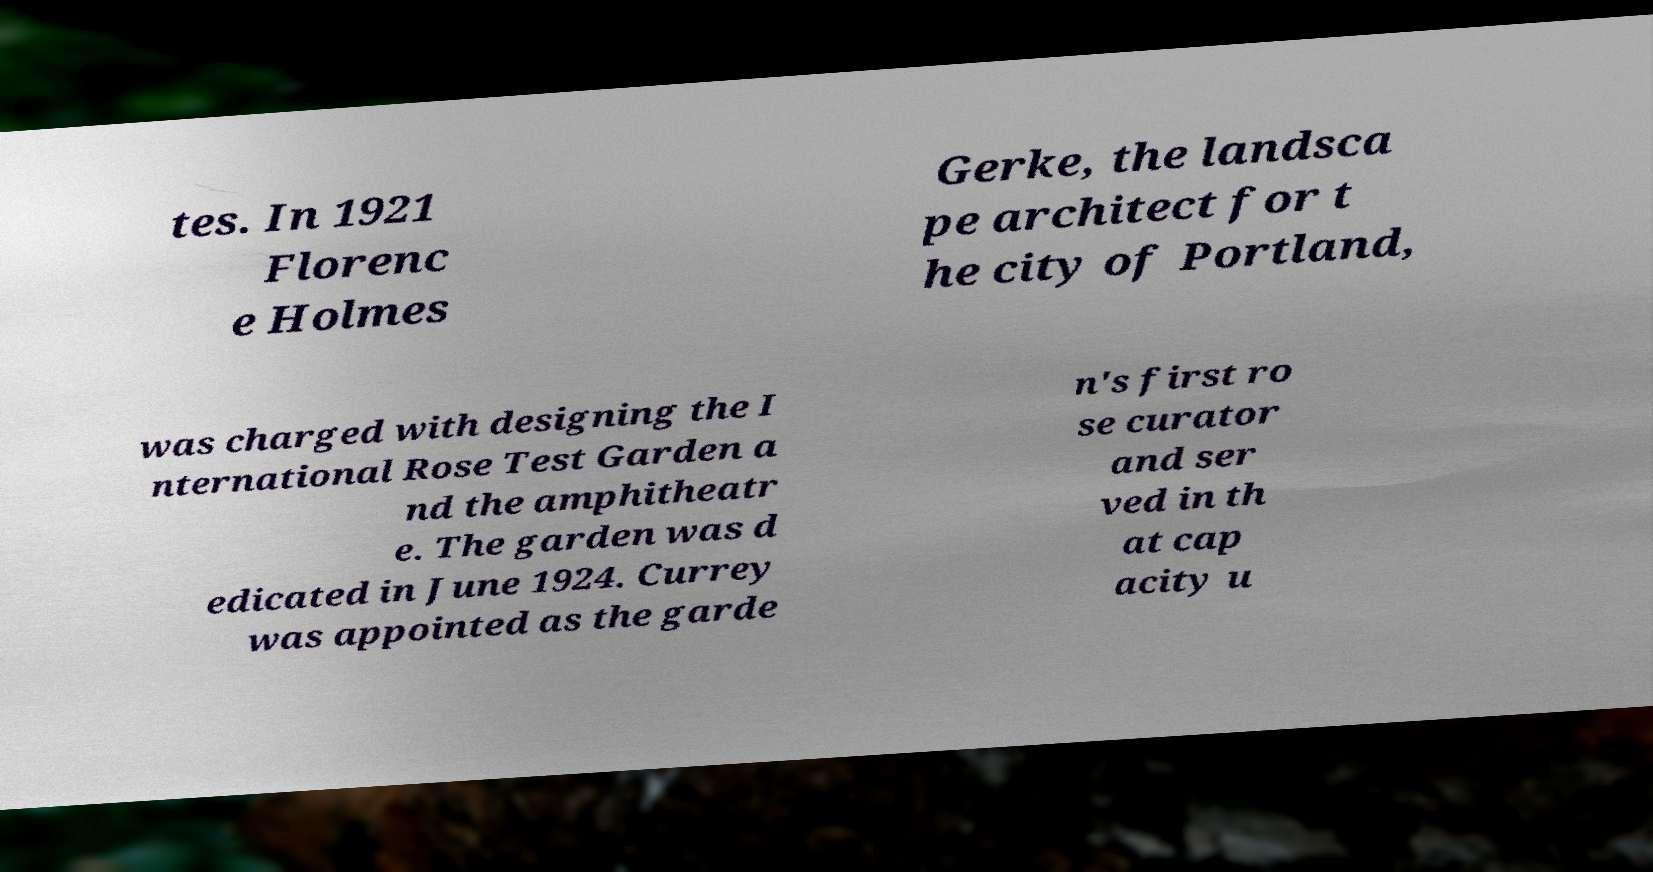For documentation purposes, I need the text within this image transcribed. Could you provide that? tes. In 1921 Florenc e Holmes Gerke, the landsca pe architect for t he city of Portland, was charged with designing the I nternational Rose Test Garden a nd the amphitheatr e. The garden was d edicated in June 1924. Currey was appointed as the garde n's first ro se curator and ser ved in th at cap acity u 